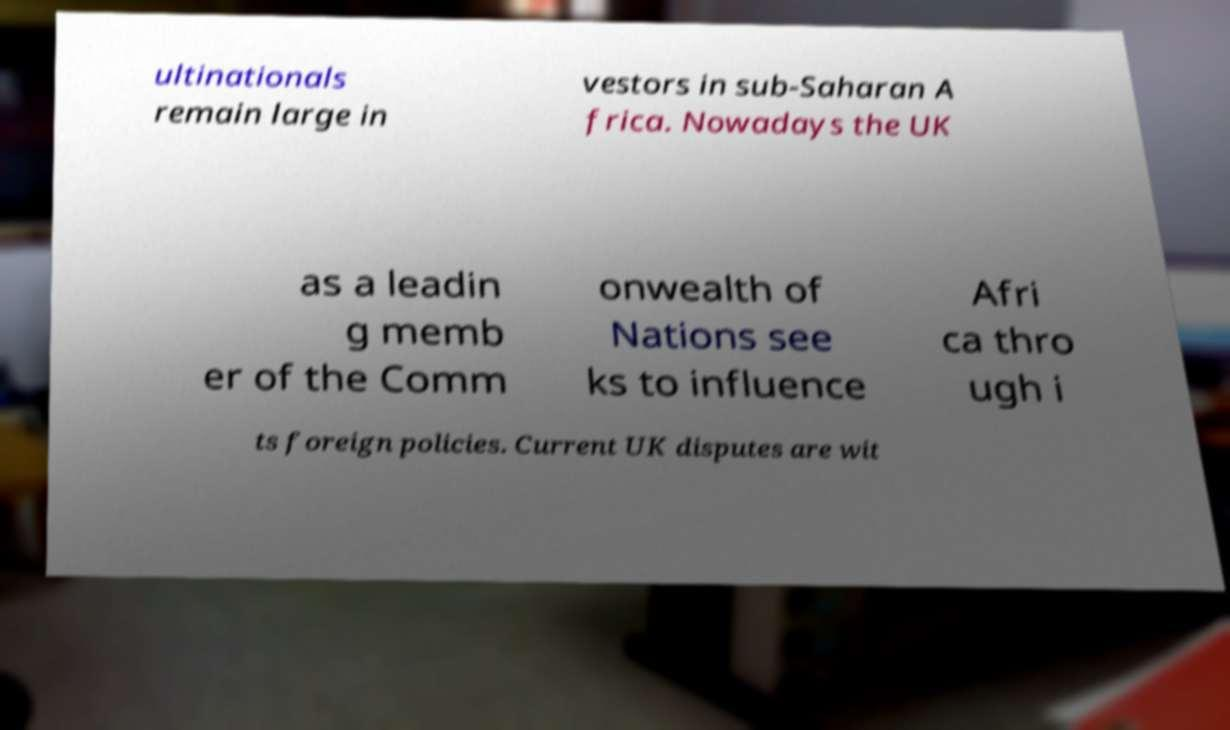Please identify and transcribe the text found in this image. ultinationals remain large in vestors in sub-Saharan A frica. Nowadays the UK as a leadin g memb er of the Comm onwealth of Nations see ks to influence Afri ca thro ugh i ts foreign policies. Current UK disputes are wit 